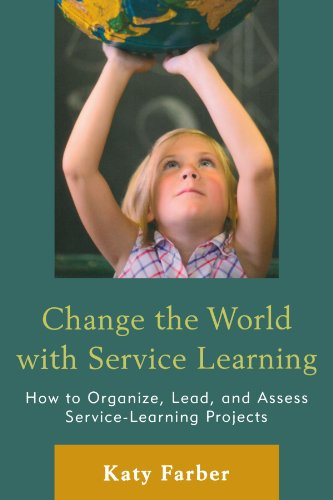Is this a pharmaceutical book? No, the book deals with service learning, specifically how it can be utilized in educational settings to impact communities positively, rather than topics related to pharmaceuticals. 